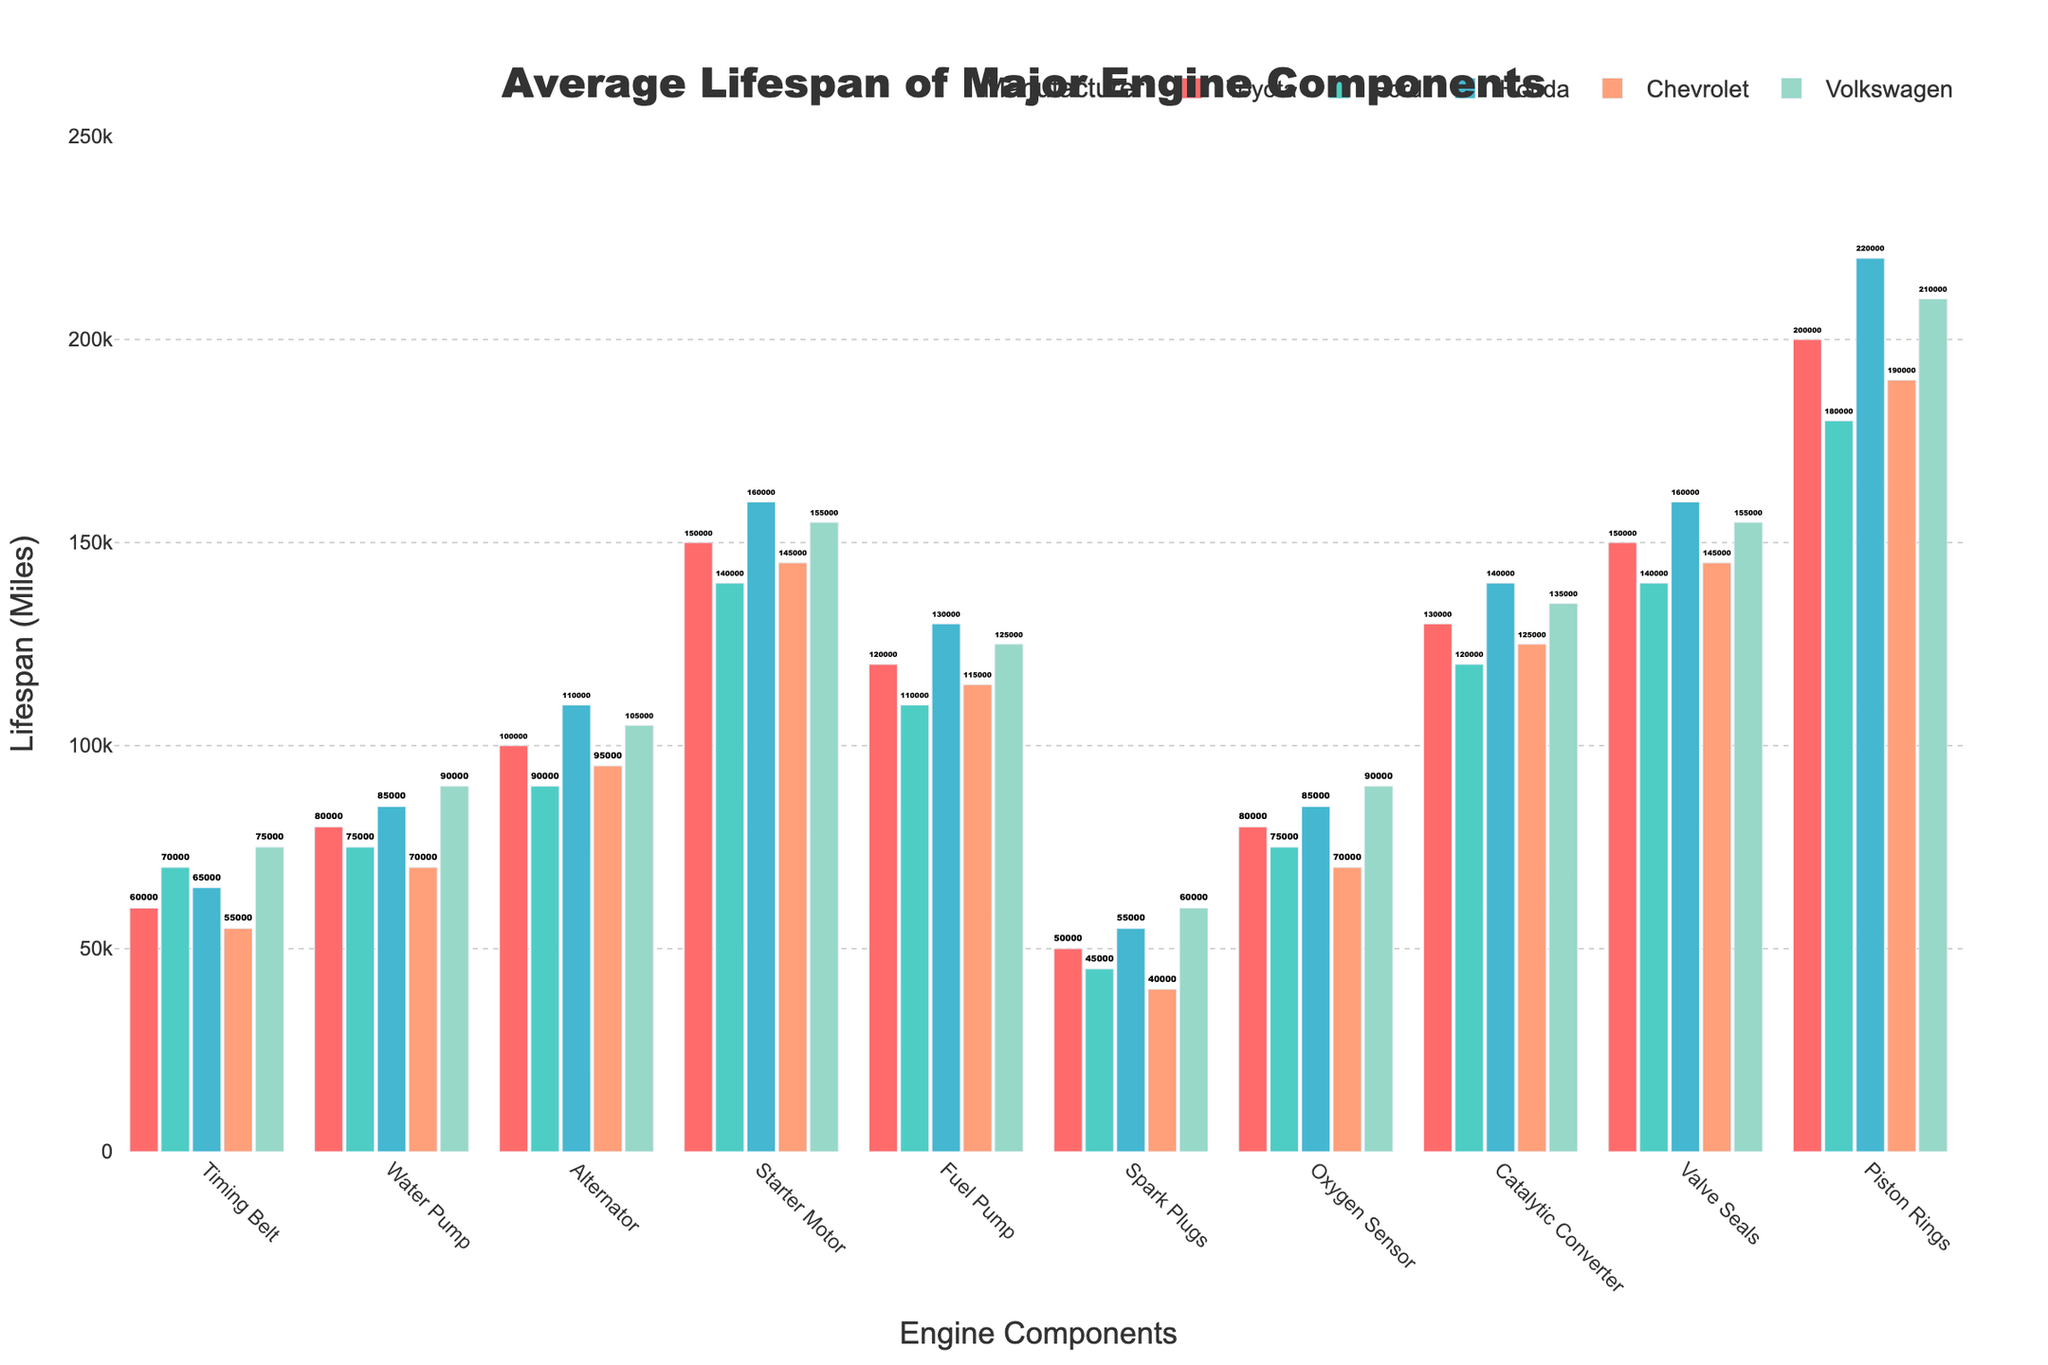What's the average lifespan of the Timing Belt across all manufacturers? Add the lifespan values together: (60000 + 70000 + 65000 + 55000 + 75000) = 325000. Then divide by the number of manufacturers (5) to get the average: 325000 / 5 = 65000
Answer: 65000 Which manufacturer has the longest lifespan for Fuel Pump? Look at the Fuel Pump row and compare the values: (Toyota: 120000, Ford: 110000, Honda: 130000, Chevrolet: 115000, Volkswagen: 125000). Honda has the highest value of 130000.
Answer: Honda How much longer does the Volkswagen Water Pump last compared to the Chevrolet Water Pump? Find the values for Volkswagen and Chevrolet Water Pump: (Volkswagen: 90000, Chevrolet: 70000). Subtract the Chevrolet value from the Volkswagen value: 90000 - 70000 = 20000
Answer: 20000 Which component has the shortest average lifespan and which manufacturer has the shortest lifespan for it? Look for the lowest average lifespan by component. Spark Plugs have the lowest values across the manufacturers. Observing the individual manufacturer values for Spark Plugs: (Toyota: 50000, Ford: 45000, Honda: 55000, Chevrolet: 40000, Volkswagen: 60000), Chevrolet has the shortest lifespan at 40000.
Answer: Spark Plugs, Chevrolet What is the difference in lifespan between the longest-lasting and shortest-lasting component for Toyota? Find the maximum and minimum values for Toyota: (Maximum, Piston Rings: 200000; Minimum, Spark Plugs: 50000). Subtract the minimum value from the maximum value: 200000 - 50000 = 150000
Answer: 150000 Which manufacturer has consistently higher lifespans across the majority of components compared to Ford? For each component, compare values between one manufacturer and Ford. Volkswagen has consistently higher values than Ford in most components: (Timing Belt: 75000 vs. 70000, Water Pump: 90000 vs. 75000, Alternator: 105000 vs. 90000, Starter Motor: 155000 vs. 140000, Fuel Pump: 125000 vs. 110000, Spark Plugs: 60000 vs. 45000, Oxygen Sensor: 90000 vs. 75000, Catalytic Converter: 135000 vs. 120000, Valve Seals: 155000 vs. 140000, Piston Rings: 210000 vs. 180000).
Answer: Volkswagen For which component is the lifespan gap between the highest and lowest manufacturer most significant? Calculate the difference for each component: 
Timing Belt: 75000 - 55000 = 20000 
Water Pump: 90000 - 70000 = 20000 
Alternator: 110000 - 90000 = 20000 
Starter Motor: 160000 - 140000 = 20000 
Fuel Pump: 130000 - 110000 = 20000 
Spark Plugs: 60000 - 40000 = 20000 
Oxygen Sensor: 90000 - 70000 = 20000 
Catalytic Converter: 140000 - 120000 = 20000 
Valve Seals: 160000 - 140000 = 20000 
Piston Rings: 220000 - 180000 = 40000 
The Piston Rings show the most significant gap at 40000.
Answer: Piston Rings 